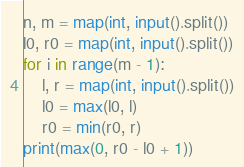<code> <loc_0><loc_0><loc_500><loc_500><_Python_>n, m = map(int, input().split())
l0, r0 = map(int, input().split())
for i in range(m - 1):
    l, r = map(int, input().split())
    l0 = max(l0, l)
    r0 = min(r0, r)
print(max(0, r0 - l0 + 1))</code> 